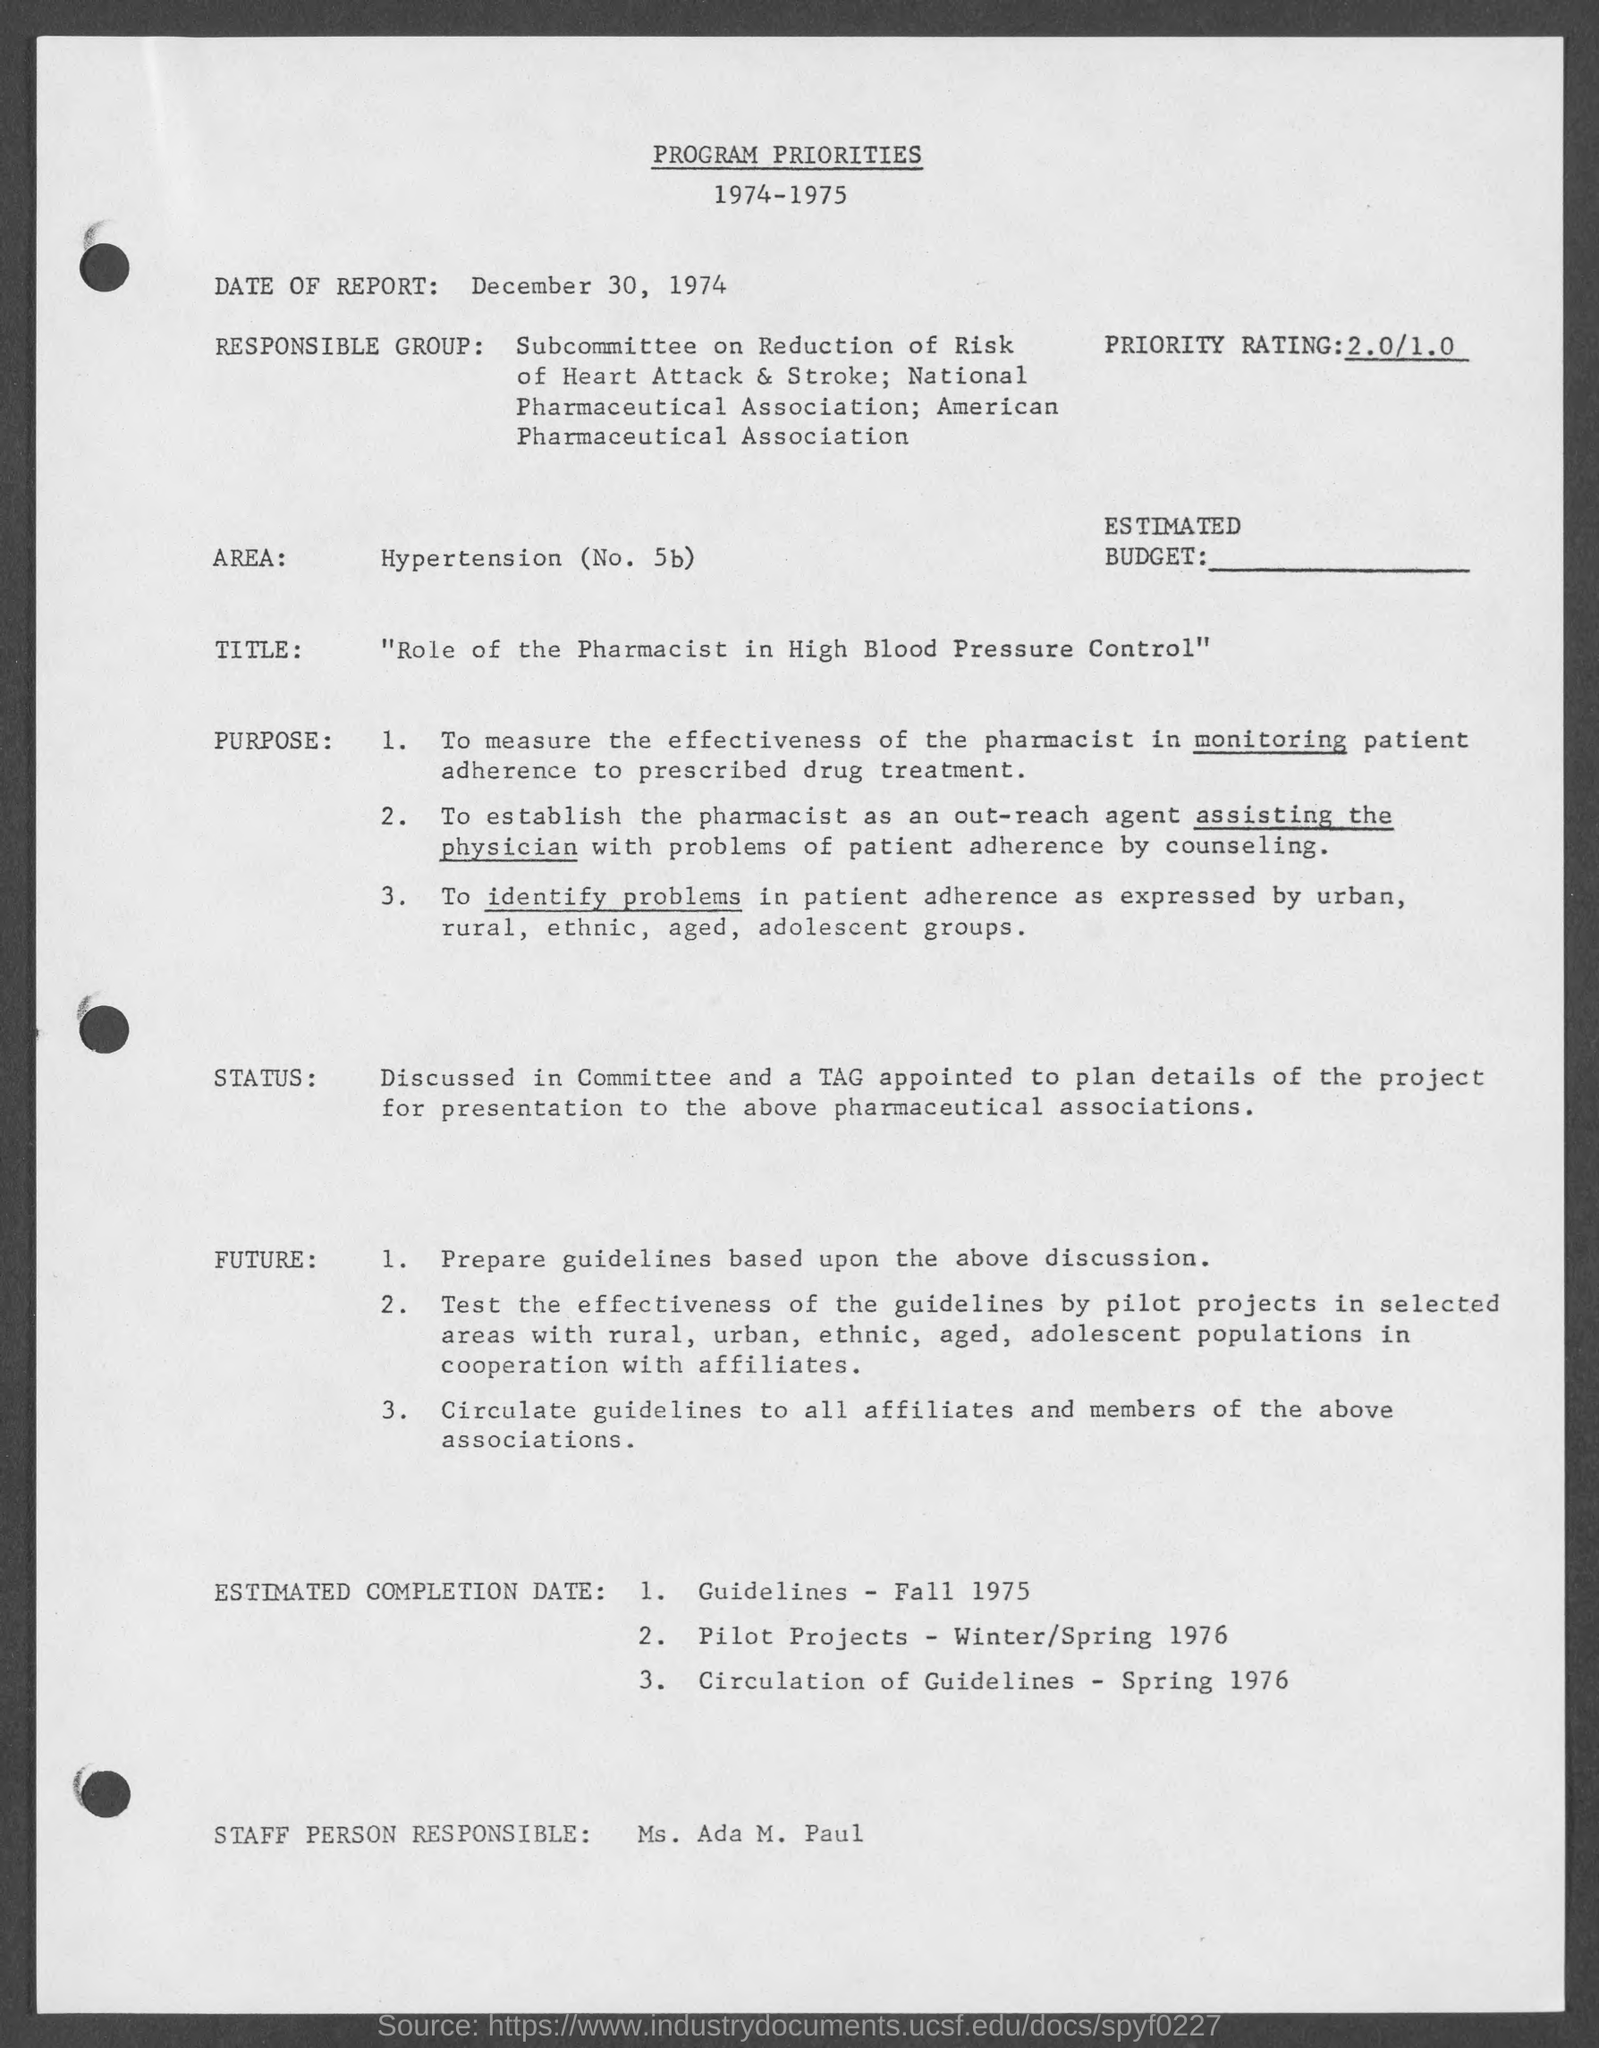Specify some key components in this picture. The date of the report is December 30, 1974. The estimated completion date for the Guidelines is fall 1975. The estimated completion date for the Circulation of Guidelines is spring 1976. It is Ms. Ada M. Paul who is responsible for the staff. 